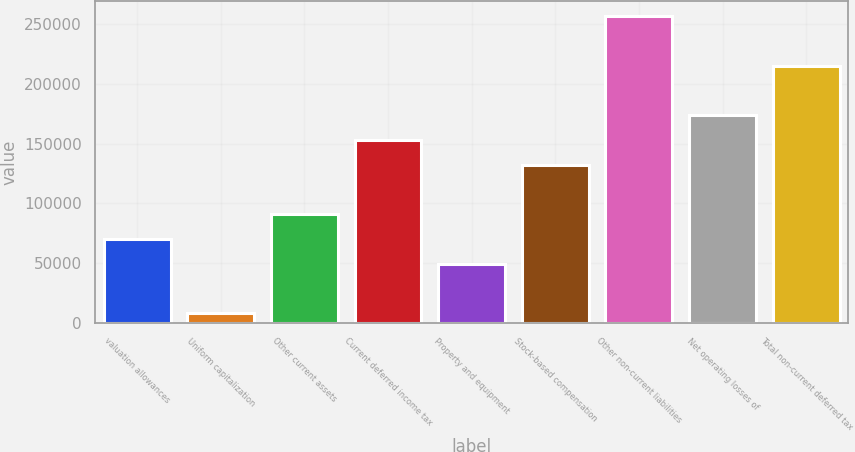<chart> <loc_0><loc_0><loc_500><loc_500><bar_chart><fcel>valuation allowances<fcel>Uniform capitalization<fcel>Other current assets<fcel>Current deferred income tax<fcel>Property and equipment<fcel>Stock-based compensation<fcel>Other non-current liabilities<fcel>Net operating losses of<fcel>Total non-current deferred tax<nl><fcel>70240.3<fcel>8131<fcel>90943.4<fcel>153053<fcel>49537.2<fcel>132350<fcel>256568<fcel>173756<fcel>215162<nl></chart> 